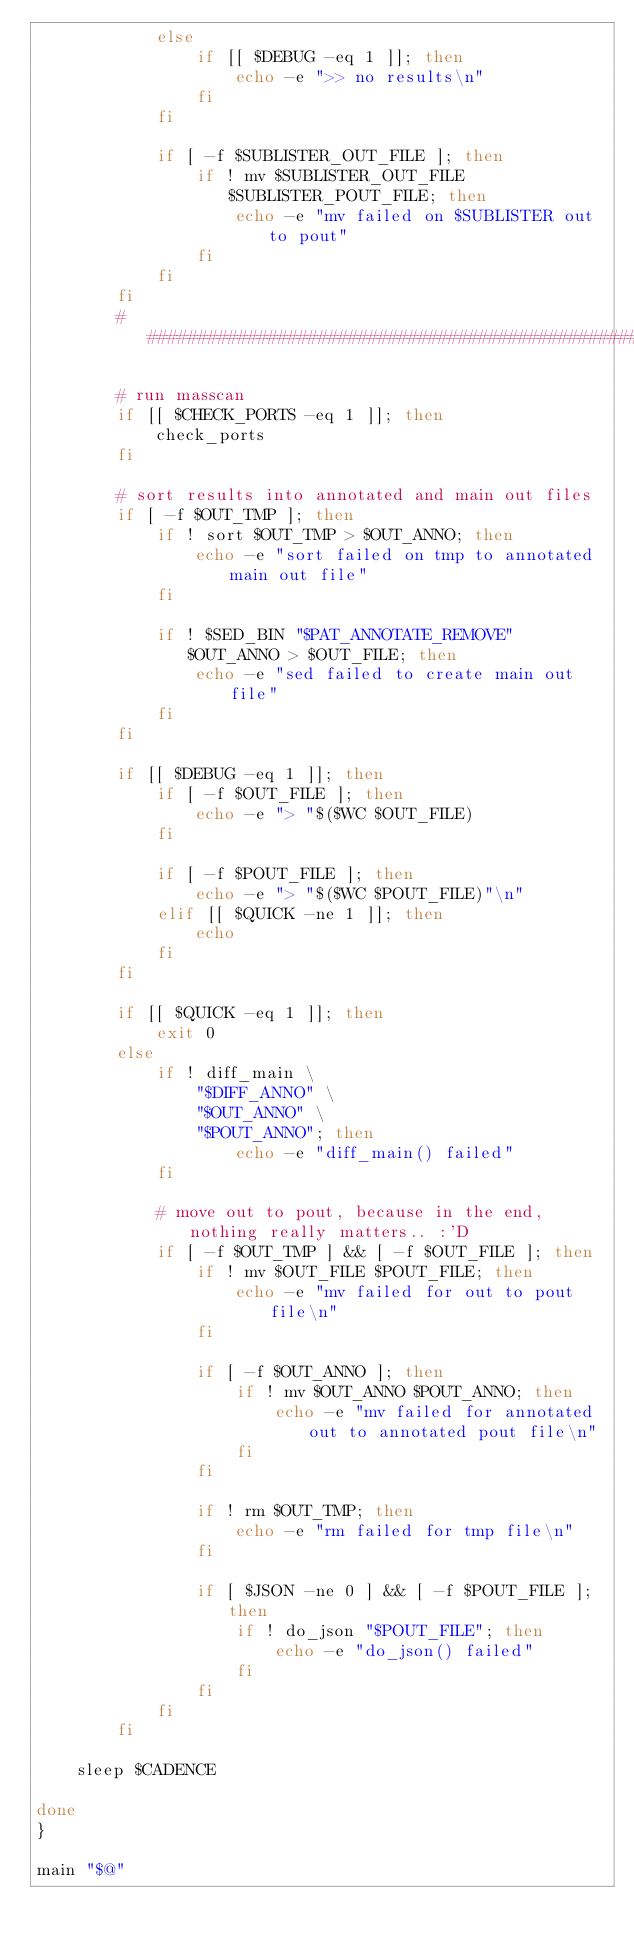<code> <loc_0><loc_0><loc_500><loc_500><_Bash_>            else
                if [[ $DEBUG -eq 1 ]]; then
                    echo -e ">> no results\n"
                fi
            fi

            if [ -f $SUBLISTER_OUT_FILE ]; then
                if ! mv $SUBLISTER_OUT_FILE $SUBLISTER_POUT_FILE; then
                    echo -e "mv failed on $SUBLISTER out to pout"
                fi
            fi
        fi
        ################################################################

        # run masscan
        if [[ $CHECK_PORTS -eq 1 ]]; then
            check_ports
        fi

        # sort results into annotated and main out files
        if [ -f $OUT_TMP ]; then
            if ! sort $OUT_TMP > $OUT_ANNO; then
                echo -e "sort failed on tmp to annotated main out file"
            fi

            if ! $SED_BIN "$PAT_ANNOTATE_REMOVE" $OUT_ANNO > $OUT_FILE; then
                echo -e "sed failed to create main out file"
            fi
        fi

        if [[ $DEBUG -eq 1 ]]; then
            if [ -f $OUT_FILE ]; then
                echo -e "> "$($WC $OUT_FILE)
            fi

            if [ -f $POUT_FILE ]; then
                echo -e "> "$($WC $POUT_FILE)"\n"
            elif [[ $QUICK -ne 1 ]]; then
                echo
            fi
        fi

        if [[ $QUICK -eq 1 ]]; then
            exit 0
        else
            if ! diff_main \
                "$DIFF_ANNO" \
                "$OUT_ANNO" \
                "$POUT_ANNO"; then
                    echo -e "diff_main() failed"
            fi

            # move out to pout, because in the end, nothing really matters.. :'D
            if [ -f $OUT_TMP ] && [ -f $OUT_FILE ]; then
                if ! mv $OUT_FILE $POUT_FILE; then
                    echo -e "mv failed for out to pout file\n"
                fi

                if [ -f $OUT_ANNO ]; then
                    if ! mv $OUT_ANNO $POUT_ANNO; then
                        echo -e "mv failed for annotated out to annotated pout file\n"
                    fi
                fi

                if ! rm $OUT_TMP; then
                    echo -e "rm failed for tmp file\n"
                fi

                if [ $JSON -ne 0 ] && [ -f $POUT_FILE ]; then
                    if ! do_json "$POUT_FILE"; then
                        echo -e "do_json() failed"
                    fi
                fi
            fi
        fi

    sleep $CADENCE

done
}

main "$@"
</code> 